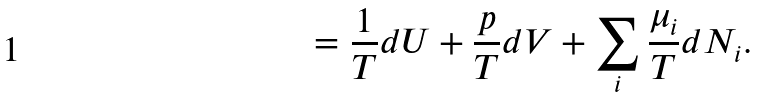<formula> <loc_0><loc_0><loc_500><loc_500>= \frac { 1 } { T } d U + \frac { p } { T } d V + \sum _ { i } \frac { \mu _ { i } } { T } d N _ { i } .</formula> 